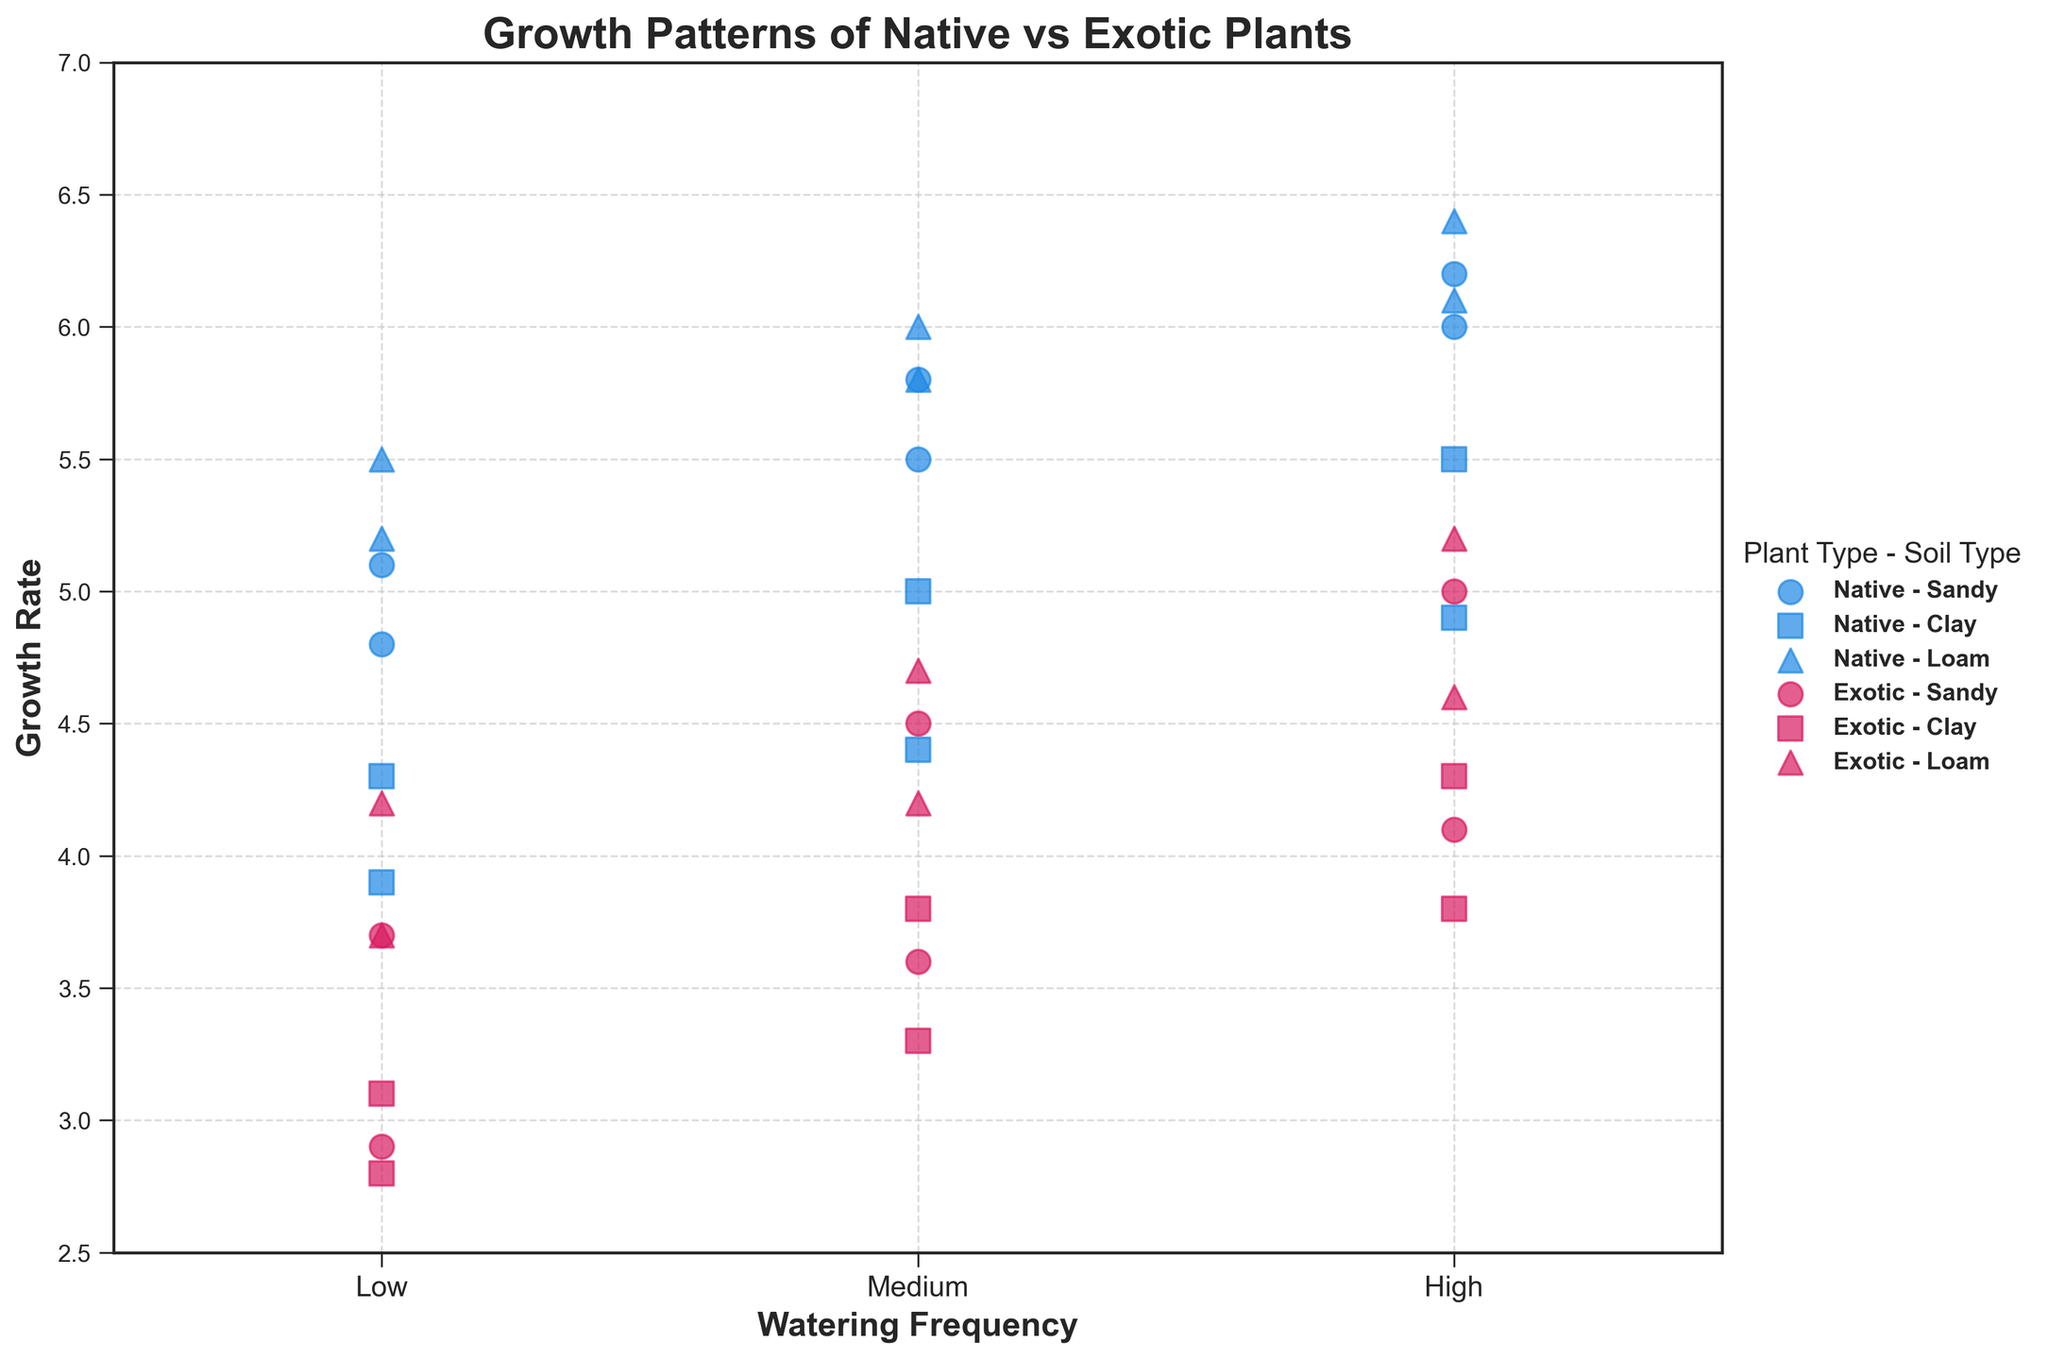What's the title of the figure? The title of the figure is displayed prominently at the top of the plot and helps to understand the context of the visualization.
Answer: Growth Patterns of Native vs Exotic Plants What do the x-axis and y-axis represent? The labels on the x-axis and y-axis describe what each axis stands for. The x-axis represents the 'Watering Frequency' and the y-axis represents the 'Growth Rate'.
Answer: Watering Frequency, Growth Rate How many distinct types of soil are represented in the plot? There are three distinct symbols in the plot, each symbol representing a different soil type: circles (Sandy), squares (Clay), and triangles (Loam).
Answer: 3 Which exotic plant grows the most in loam soil with high watering frequency? By identifying the growth rates of exotic plants in loam soil with high watering frequency, we observe that Bamboo has the highest growth rate of 5.2.
Answer: Bamboo Between native and exotic plants, which group shows a higher overall growth rate in sandy soil? By observing the scatter points for both native and exotic plants in sandy soil across all watering frequencies, native plants (e.g., Black-Eyed Susan and Purple Coneflower) show a higher overall growth rate compared to exotic plants (Bamboo and Japanese Maple).
Answer: Native What is the growth rate difference between native and exotic plants in clay soil with medium watering? Compare the scatter points for native and exotic plants in clay soil with medium watering. Native plants (Black-Eyed Susan and Purple Coneflower) have an average growth rate of approximately 4.7, while exotic plants (Bamboo and Japanese Maple) have an average growth rate of approximately 3.55. So, the difference is 4.7 - 3.55.
Answer: 1.15 Which combination of plant type, soil type, and watering frequency results in the highest growth rate overall? The scatter point with the highest position on the y-axis represents the highest growth rate. For 'Native - Loam - High', it has the highest position among all, with a growth rate of 6.4 for Black-Eyed Susan.
Answer: Native, Loam, High What is the average growth rate for native plants in loam soil? Identify the growth rates of native plants in loam soil (Low: 5.5, Medium: 6.0, High: 6.4), then calculate the average: (5.5 + 6.0 + 6.4) / 3 = 5.97.
Answer: 5.97 For which soil type do exotic plants perform best? By comparing the growth rates of exotic plants across different soil types under high watering frequency conditions, loam soil appears to have the highest growth rate for most exotic plants (5.2 for Bamboo).
Answer: Loam How does the growth rate of Japanese Maple compare between clay and sandy soil with medium watering frequency? Check the scatter points for Japanese Maple in both clay and sandy soil with medium watering. In clay soil, the growth rate is 3.8, and in sandy soil, it is 3.6. The growth rate in clay soil is higher by 0.2.
Answer: Clay is higher by 0.2 